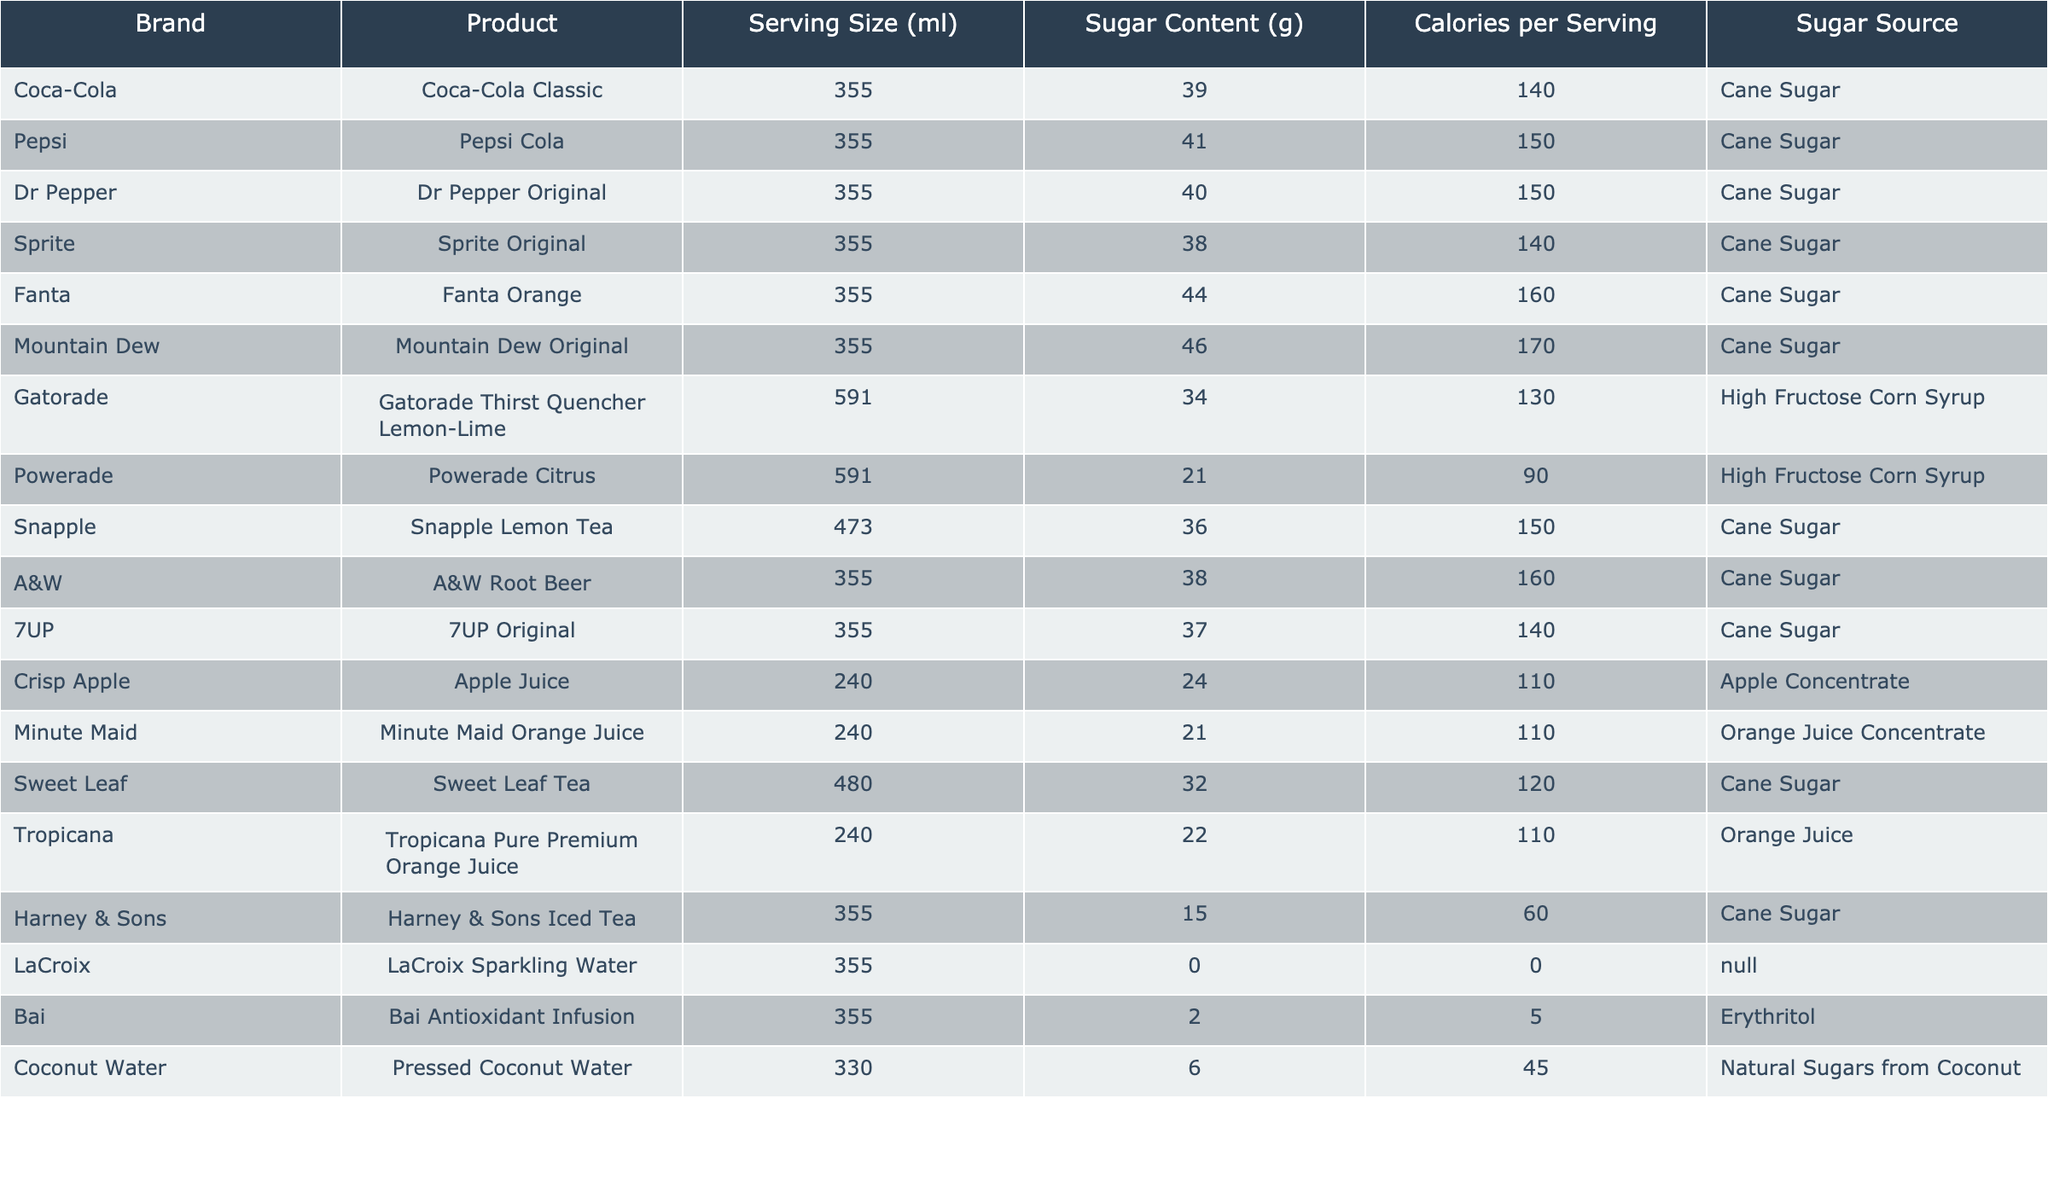What is the sugar content in Coca-Cola Classic? In the table, under the 'Sugar Content (g)' column for Coca-Cola Classic, the value listed is 39 grams.
Answer: 39 grams Which drink has the highest sugar content? Upon reviewing the table, Fanta Orange has the highest sugar content at 44 grams per serving.
Answer: Fanta Orange What are the calories per serving for Mountain Dew Original? Looking at the 'Calories per Serving' column for Mountain Dew Original, the value is 170 calories.
Answer: 170 calories Which drink uses High Fructose Corn Syrup as its sugar source? In the 'Sugar Source' column, Gatorade and Powerade are listed with High Fructose Corn Syrup.
Answer: Gatorade and Powerade What is the average sugar content of the drinks listed in the table? To calculate the average sugar content, sum the sugar values: (39 + 41 + 40 + 38 + 44 + 46 + 34 + 21 + 36 + 38 + 37 + 24 + 21 + 32 + 22 + 15 + 0 + 2 + 6) = 414 grams. There are 18 drinks, so the average is 414/18 ≈ 23 grams.
Answer: 23 grams Is Snapple Lemon Tea higher in sugar content than Powerade Citrus? Comparing the sugar content, Snapple Lemon Tea has 36 grams, and Powerade Citrus has 21 grams, making Snapple Lemon Tea higher.
Answer: Yes What is the difference in sugar content between Fanta Orange and Sprite Original? Fanta Orange has 44 grams and Sprite Original has 38 grams. The difference is 44 - 38 = 6 grams.
Answer: 6 grams If you combine the sugar content of Coca-Cola Classic and Pepsi Cola, what is the total? Adding the sugar content of both, Coca-Cola Classic has 39 grams and Pepsi Cola has 41 grams. Thus, the total is 39 + 41 = 80 grams.
Answer: 80 grams Does LaCroix contain any sugar? The sugar content listed for LaCroix in the table is 0 grams, indicating that it does not contain sugar.
Answer: No What percentage of the total drinks use cane sugar as their sugar source? There are 11 drinks that use cane sugar out of 18 total drinks. The percentage calculates as (11/18) * 100 ≈ 61.1%.
Answer: Approximately 61.1% 